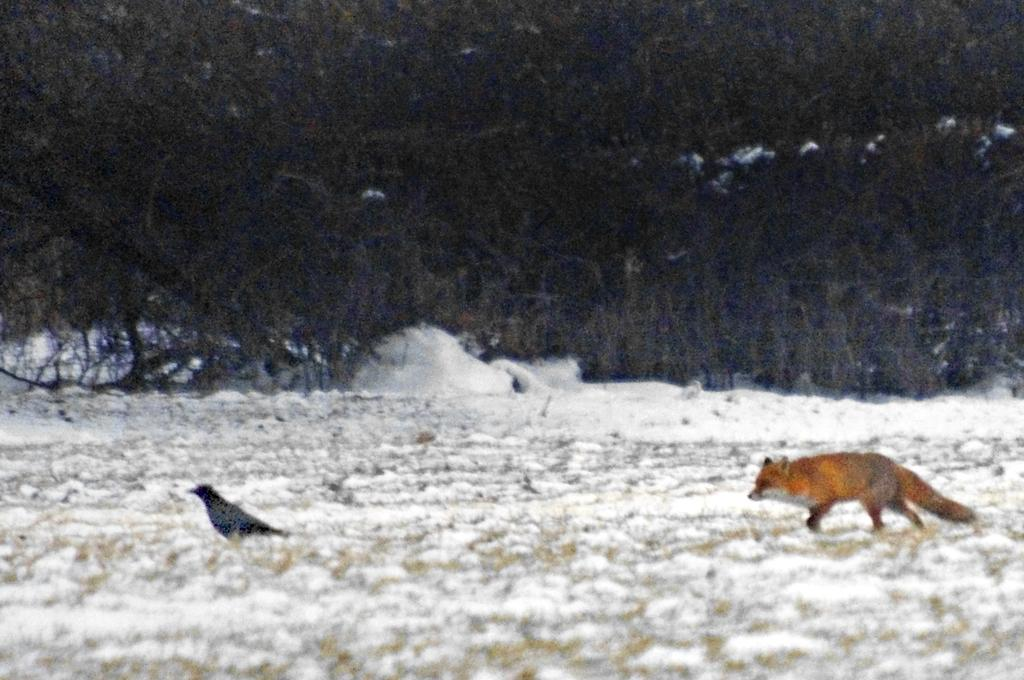What type of animal can be seen in the image? There is an animal in the image. Can you identify the specific type of bird in the image? There is a bird in the image. Where are the animal and bird located in the image? Both the animal and bird are on the ground. What is the condition of the ground in the image? There is snow on the ground. What can be seen in the background of the image? There are trees in the background of the image. How many cats are playing on the skate in the image? There are no cats or skates present in the image. Can you tell me the color of the ladybug on the tree in the image? There is no ladybug present in the image; only the animal, bird, snow, and trees are visible. 